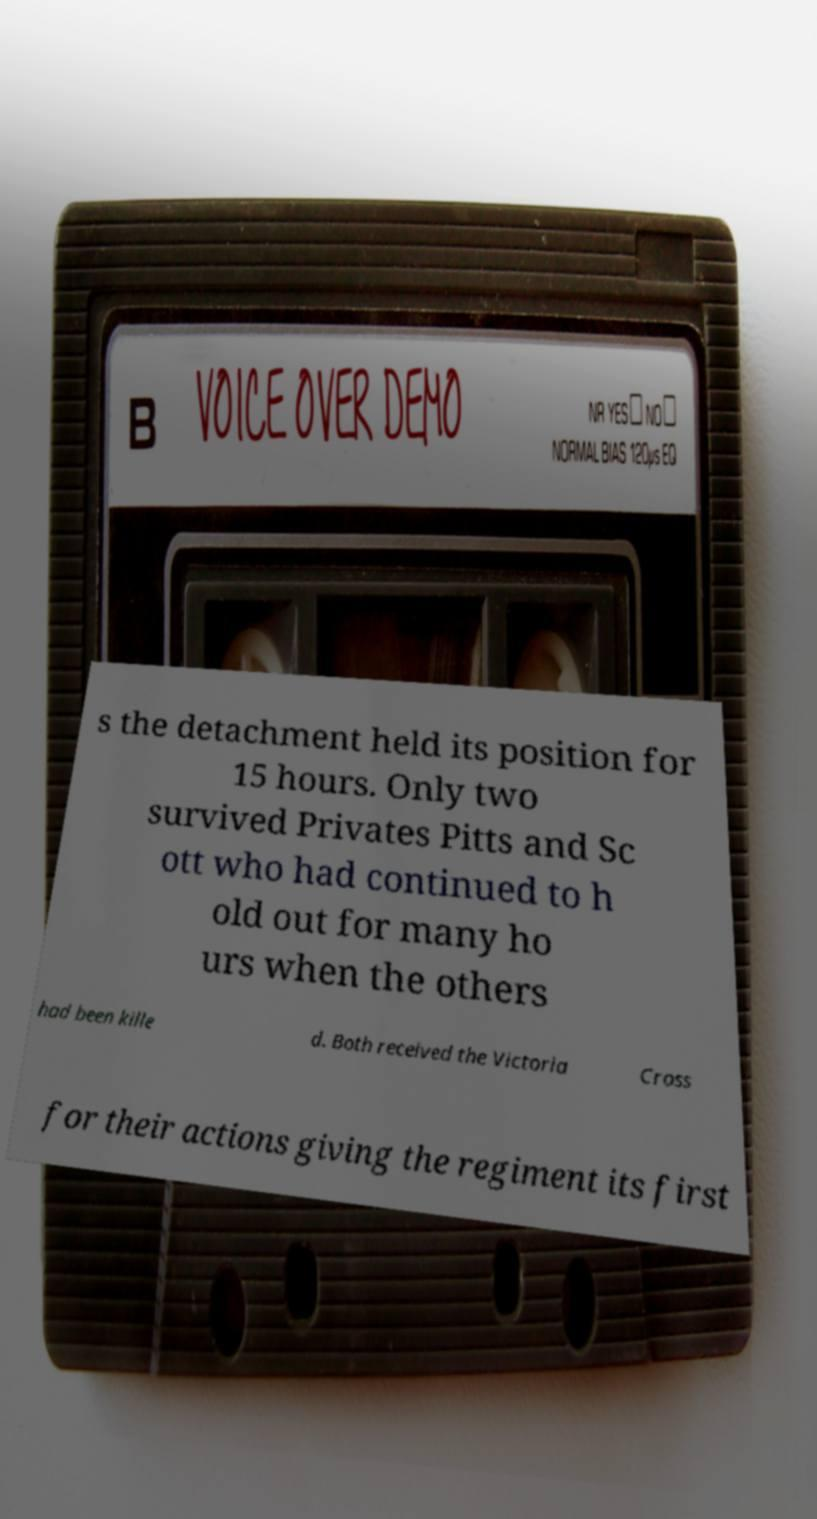For documentation purposes, I need the text within this image transcribed. Could you provide that? s the detachment held its position for 15 hours. Only two survived Privates Pitts and Sc ott who had continued to h old out for many ho urs when the others had been kille d. Both received the Victoria Cross for their actions giving the regiment its first 